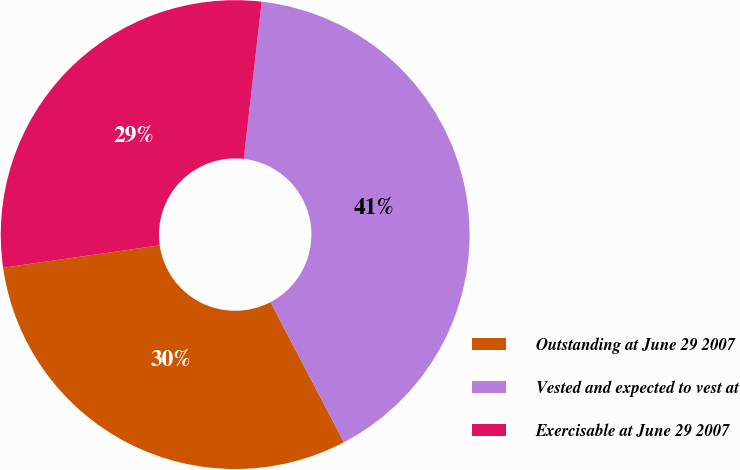<chart> <loc_0><loc_0><loc_500><loc_500><pie_chart><fcel>Outstanding at June 29 2007<fcel>Vested and expected to vest at<fcel>Exercisable at June 29 2007<nl><fcel>30.42%<fcel>40.52%<fcel>29.06%<nl></chart> 